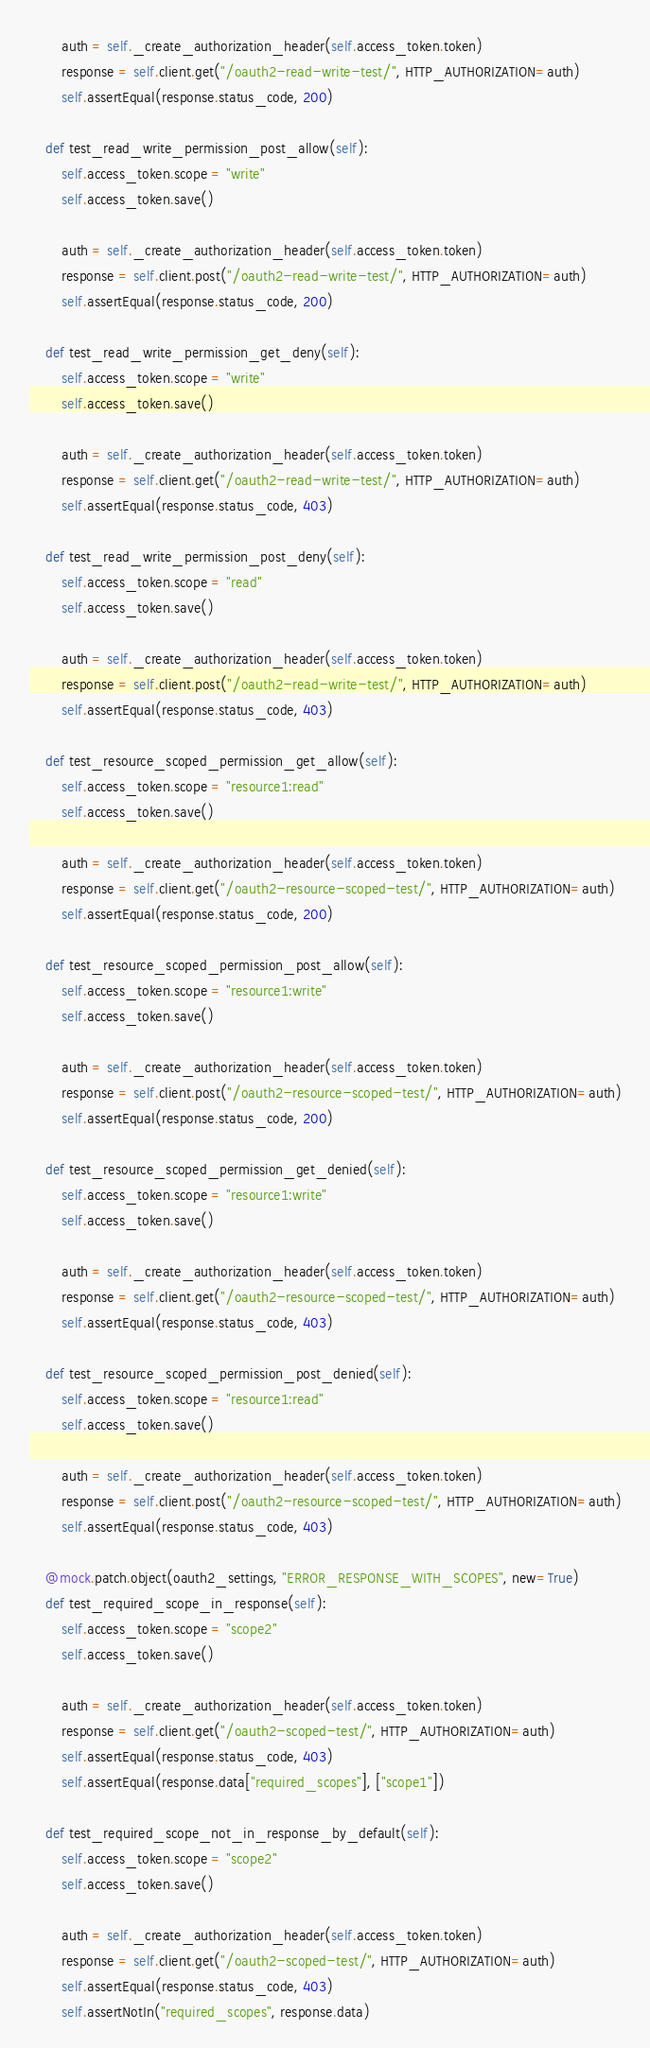Convert code to text. <code><loc_0><loc_0><loc_500><loc_500><_Python_>
        auth = self._create_authorization_header(self.access_token.token)
        response = self.client.get("/oauth2-read-write-test/", HTTP_AUTHORIZATION=auth)
        self.assertEqual(response.status_code, 200)

    def test_read_write_permission_post_allow(self):
        self.access_token.scope = "write"
        self.access_token.save()

        auth = self._create_authorization_header(self.access_token.token)
        response = self.client.post("/oauth2-read-write-test/", HTTP_AUTHORIZATION=auth)
        self.assertEqual(response.status_code, 200)

    def test_read_write_permission_get_deny(self):
        self.access_token.scope = "write"
        self.access_token.save()

        auth = self._create_authorization_header(self.access_token.token)
        response = self.client.get("/oauth2-read-write-test/", HTTP_AUTHORIZATION=auth)
        self.assertEqual(response.status_code, 403)

    def test_read_write_permission_post_deny(self):
        self.access_token.scope = "read"
        self.access_token.save()

        auth = self._create_authorization_header(self.access_token.token)
        response = self.client.post("/oauth2-read-write-test/", HTTP_AUTHORIZATION=auth)
        self.assertEqual(response.status_code, 403)

    def test_resource_scoped_permission_get_allow(self):
        self.access_token.scope = "resource1:read"
        self.access_token.save()

        auth = self._create_authorization_header(self.access_token.token)
        response = self.client.get("/oauth2-resource-scoped-test/", HTTP_AUTHORIZATION=auth)
        self.assertEqual(response.status_code, 200)

    def test_resource_scoped_permission_post_allow(self):
        self.access_token.scope = "resource1:write"
        self.access_token.save()

        auth = self._create_authorization_header(self.access_token.token)
        response = self.client.post("/oauth2-resource-scoped-test/", HTTP_AUTHORIZATION=auth)
        self.assertEqual(response.status_code, 200)

    def test_resource_scoped_permission_get_denied(self):
        self.access_token.scope = "resource1:write"
        self.access_token.save()

        auth = self._create_authorization_header(self.access_token.token)
        response = self.client.get("/oauth2-resource-scoped-test/", HTTP_AUTHORIZATION=auth)
        self.assertEqual(response.status_code, 403)

    def test_resource_scoped_permission_post_denied(self):
        self.access_token.scope = "resource1:read"
        self.access_token.save()

        auth = self._create_authorization_header(self.access_token.token)
        response = self.client.post("/oauth2-resource-scoped-test/", HTTP_AUTHORIZATION=auth)
        self.assertEqual(response.status_code, 403)

    @mock.patch.object(oauth2_settings, "ERROR_RESPONSE_WITH_SCOPES", new=True)
    def test_required_scope_in_response(self):
        self.access_token.scope = "scope2"
        self.access_token.save()

        auth = self._create_authorization_header(self.access_token.token)
        response = self.client.get("/oauth2-scoped-test/", HTTP_AUTHORIZATION=auth)
        self.assertEqual(response.status_code, 403)
        self.assertEqual(response.data["required_scopes"], ["scope1"])

    def test_required_scope_not_in_response_by_default(self):
        self.access_token.scope = "scope2"
        self.access_token.save()

        auth = self._create_authorization_header(self.access_token.token)
        response = self.client.get("/oauth2-scoped-test/", HTTP_AUTHORIZATION=auth)
        self.assertEqual(response.status_code, 403)
        self.assertNotIn("required_scopes", response.data)
</code> 